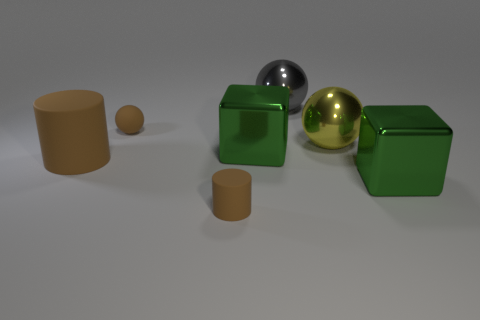How many large things are either green shiny objects or gray objects?
Your answer should be compact. 3. What is the size of the yellow object that is the same shape as the big gray metallic object?
Ensure brevity in your answer.  Large. Is there anything else that is the same size as the gray object?
Offer a terse response. Yes. The green cube in front of the brown matte cylinder left of the tiny brown cylinder is made of what material?
Make the answer very short. Metal. How many shiny objects are either large green objects or small things?
Keep it short and to the point. 2. There is another big metallic object that is the same shape as the yellow thing; what color is it?
Give a very brief answer. Gray. What number of small matte things are the same color as the tiny rubber cylinder?
Make the answer very short. 1. There is a tiny object in front of the rubber sphere; are there any matte spheres right of it?
Provide a succinct answer. No. What number of big things are behind the big cylinder and on the left side of the gray sphere?
Give a very brief answer. 1. How many big yellow spheres have the same material as the large brown cylinder?
Make the answer very short. 0. 